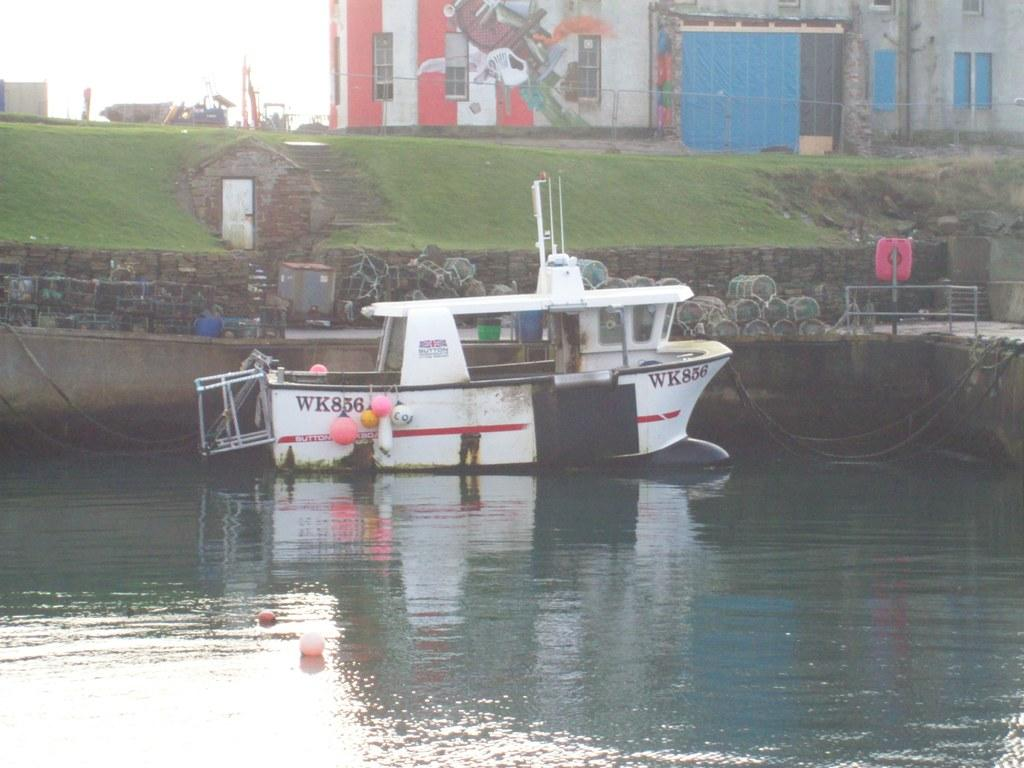What is the main subject of the image? The main subject of the image is a boat. Where is the boat located in the image? The boat is parked on the water in the image. What is present on the ground behind the boat? There is a load present on the ground behind the boat. What type of structures can be seen in the image? There are buildings and a house in the image. What type of vegetation is present in the image? Grass is present in the image. What additional decorative elements can be seen in the image? Balloons are visible in the image. How many pigs are present in the image? There are no pigs present in the image. What type of egg is being used to decorate the boat in the image? There are no eggs present in the image, let alone being used to decorate the boat. 